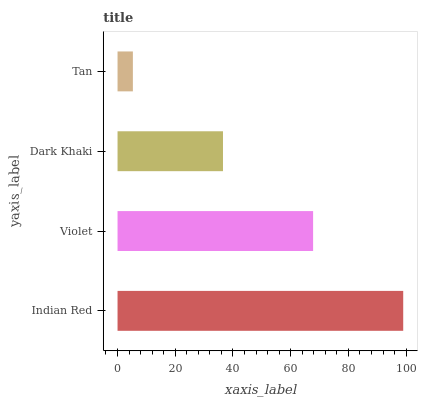Is Tan the minimum?
Answer yes or no. Yes. Is Indian Red the maximum?
Answer yes or no. Yes. Is Violet the minimum?
Answer yes or no. No. Is Violet the maximum?
Answer yes or no. No. Is Indian Red greater than Violet?
Answer yes or no. Yes. Is Violet less than Indian Red?
Answer yes or no. Yes. Is Violet greater than Indian Red?
Answer yes or no. No. Is Indian Red less than Violet?
Answer yes or no. No. Is Violet the high median?
Answer yes or no. Yes. Is Dark Khaki the low median?
Answer yes or no. Yes. Is Tan the high median?
Answer yes or no. No. Is Tan the low median?
Answer yes or no. No. 